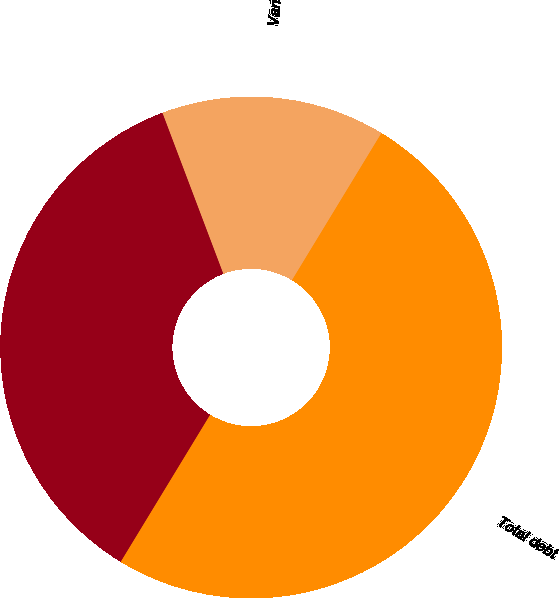Convert chart. <chart><loc_0><loc_0><loc_500><loc_500><pie_chart><fcel>Variable rate debt<fcel>Fixed rate debt<fcel>Total debt<nl><fcel>14.45%<fcel>35.55%<fcel>50.0%<nl></chart> 